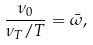Convert formula to latex. <formula><loc_0><loc_0><loc_500><loc_500>\frac { \nu _ { 0 } } { \nu _ { T } / T } = \bar { \omega } ,</formula> 